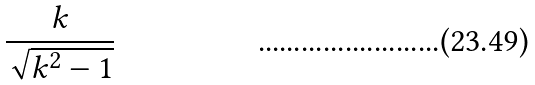<formula> <loc_0><loc_0><loc_500><loc_500>\frac { k } { \sqrt { k ^ { 2 } - 1 } }</formula> 